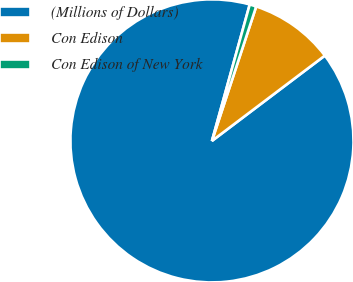<chart> <loc_0><loc_0><loc_500><loc_500><pie_chart><fcel>(Millions of Dollars)<fcel>Con Edison<fcel>Con Edison of New York<nl><fcel>89.6%<fcel>9.64%<fcel>0.76%<nl></chart> 